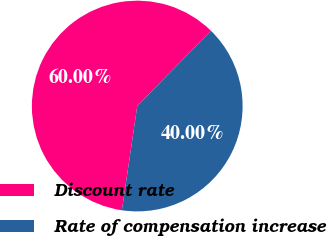<chart> <loc_0><loc_0><loc_500><loc_500><pie_chart><fcel>Discount rate<fcel>Rate of compensation increase<nl><fcel>60.0%<fcel>40.0%<nl></chart> 